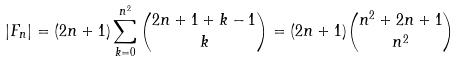<formula> <loc_0><loc_0><loc_500><loc_500>| F _ { n } | = ( 2 n + 1 ) \sum _ { k = 0 } ^ { n ^ { 2 } } \binom { 2 n + 1 + k - 1 } { k } = ( 2 n + 1 ) \binom { n ^ { 2 } + 2 n + 1 } { n ^ { 2 } }</formula> 